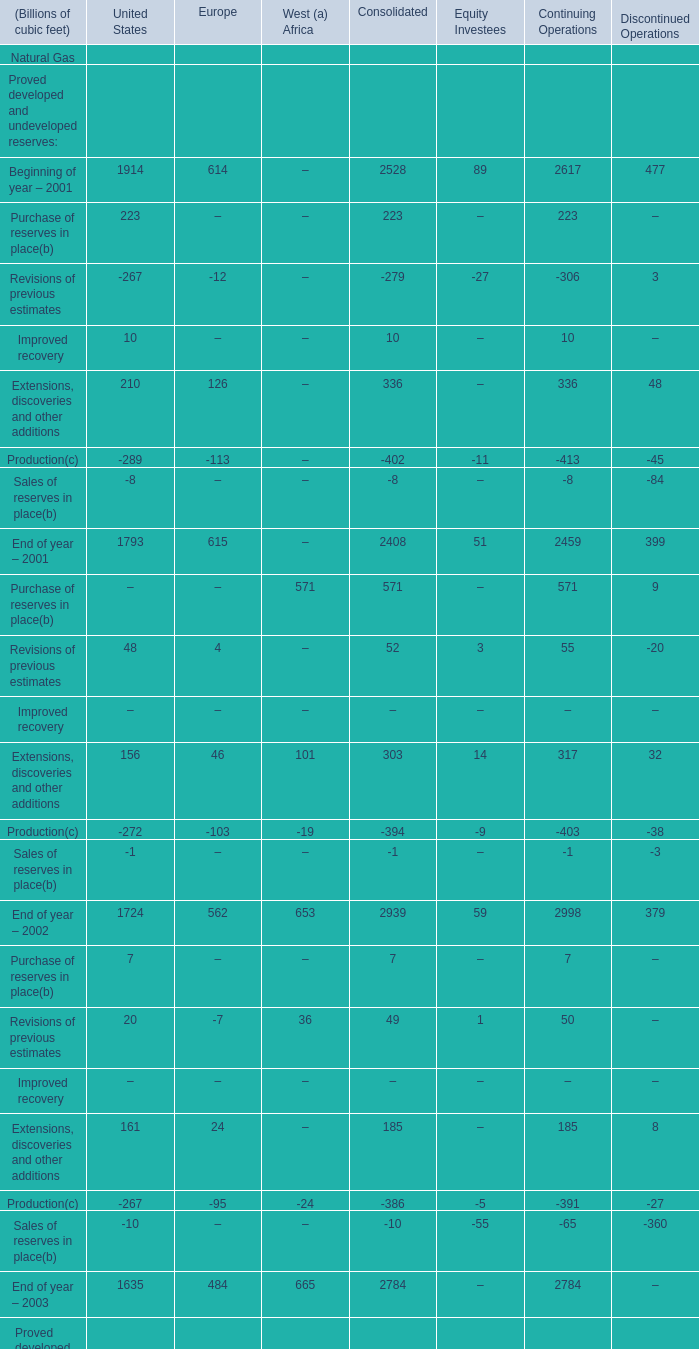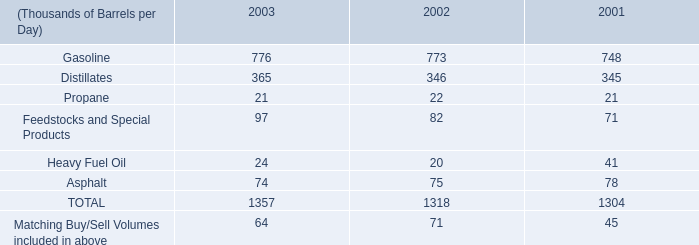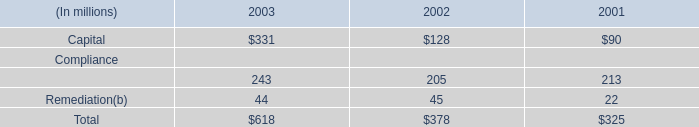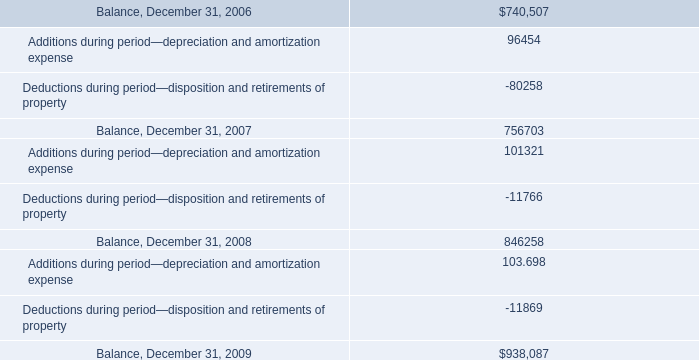what's the total amount of End of year – 2003 of Continuing Operations, Deductions during period—disposition and retirements of property, and End of year – 2001 of United States ? 
Computations: ((2784.0 + 11869.0) + 1793.0)
Answer: 16446.0. 